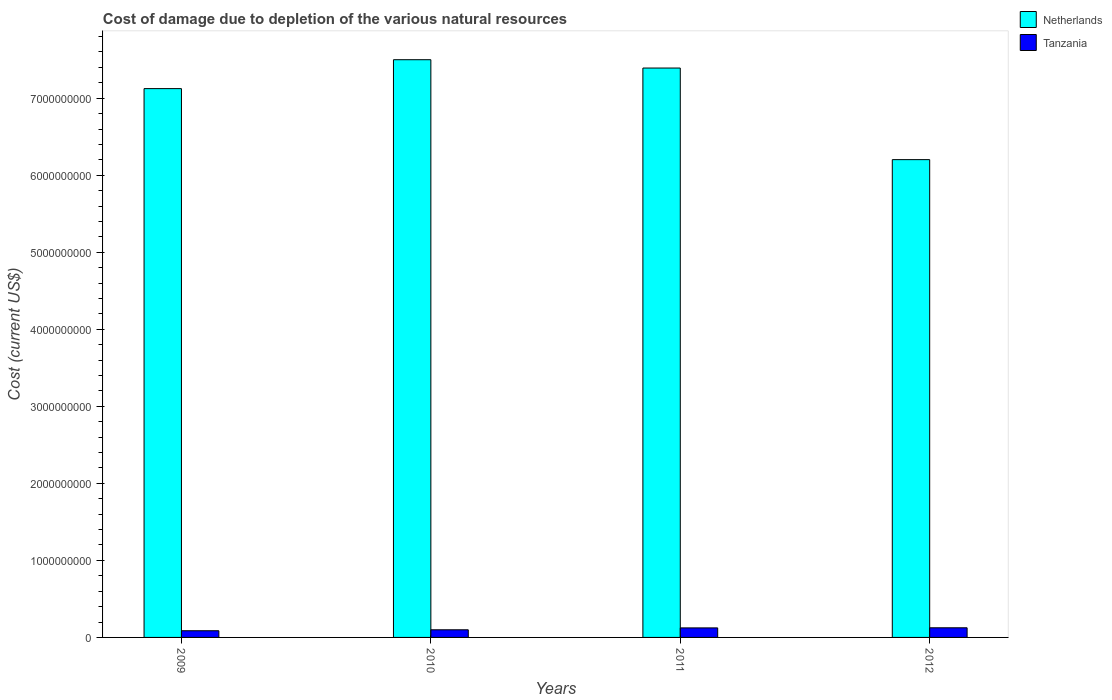How many different coloured bars are there?
Offer a terse response. 2. How many groups of bars are there?
Your response must be concise. 4. Are the number of bars per tick equal to the number of legend labels?
Your response must be concise. Yes. How many bars are there on the 1st tick from the right?
Your answer should be very brief. 2. What is the label of the 4th group of bars from the left?
Provide a succinct answer. 2012. What is the cost of damage caused due to the depletion of various natural resources in Netherlands in 2009?
Ensure brevity in your answer.  7.12e+09. Across all years, what is the maximum cost of damage caused due to the depletion of various natural resources in Tanzania?
Give a very brief answer. 1.25e+08. Across all years, what is the minimum cost of damage caused due to the depletion of various natural resources in Netherlands?
Offer a terse response. 6.20e+09. In which year was the cost of damage caused due to the depletion of various natural resources in Tanzania maximum?
Keep it short and to the point. 2012. In which year was the cost of damage caused due to the depletion of various natural resources in Netherlands minimum?
Provide a succinct answer. 2012. What is the total cost of damage caused due to the depletion of various natural resources in Netherlands in the graph?
Your answer should be compact. 2.82e+1. What is the difference between the cost of damage caused due to the depletion of various natural resources in Tanzania in 2009 and that in 2011?
Provide a succinct answer. -3.69e+07. What is the difference between the cost of damage caused due to the depletion of various natural resources in Netherlands in 2011 and the cost of damage caused due to the depletion of various natural resources in Tanzania in 2010?
Give a very brief answer. 7.29e+09. What is the average cost of damage caused due to the depletion of various natural resources in Tanzania per year?
Your answer should be compact. 1.09e+08. In the year 2011, what is the difference between the cost of damage caused due to the depletion of various natural resources in Tanzania and cost of damage caused due to the depletion of various natural resources in Netherlands?
Give a very brief answer. -7.27e+09. In how many years, is the cost of damage caused due to the depletion of various natural resources in Netherlands greater than 3400000000 US$?
Give a very brief answer. 4. What is the ratio of the cost of damage caused due to the depletion of various natural resources in Netherlands in 2009 to that in 2010?
Offer a terse response. 0.95. Is the cost of damage caused due to the depletion of various natural resources in Tanzania in 2009 less than that in 2011?
Your answer should be very brief. Yes. Is the difference between the cost of damage caused due to the depletion of various natural resources in Tanzania in 2010 and 2012 greater than the difference between the cost of damage caused due to the depletion of various natural resources in Netherlands in 2010 and 2012?
Make the answer very short. No. What is the difference between the highest and the second highest cost of damage caused due to the depletion of various natural resources in Netherlands?
Give a very brief answer. 1.08e+08. What is the difference between the highest and the lowest cost of damage caused due to the depletion of various natural resources in Tanzania?
Offer a terse response. 3.82e+07. In how many years, is the cost of damage caused due to the depletion of various natural resources in Netherlands greater than the average cost of damage caused due to the depletion of various natural resources in Netherlands taken over all years?
Offer a very short reply. 3. Is the sum of the cost of damage caused due to the depletion of various natural resources in Tanzania in 2010 and 2011 greater than the maximum cost of damage caused due to the depletion of various natural resources in Netherlands across all years?
Your answer should be compact. No. What does the 2nd bar from the left in 2010 represents?
Provide a succinct answer. Tanzania. What does the 1st bar from the right in 2011 represents?
Keep it short and to the point. Tanzania. How many bars are there?
Your answer should be compact. 8. Are the values on the major ticks of Y-axis written in scientific E-notation?
Keep it short and to the point. No. What is the title of the graph?
Your answer should be compact. Cost of damage due to depletion of the various natural resources. What is the label or title of the X-axis?
Your response must be concise. Years. What is the label or title of the Y-axis?
Give a very brief answer. Cost (current US$). What is the Cost (current US$) of Netherlands in 2009?
Your answer should be very brief. 7.12e+09. What is the Cost (current US$) of Tanzania in 2009?
Provide a short and direct response. 8.69e+07. What is the Cost (current US$) of Netherlands in 2010?
Provide a succinct answer. 7.50e+09. What is the Cost (current US$) of Tanzania in 2010?
Ensure brevity in your answer.  9.92e+07. What is the Cost (current US$) of Netherlands in 2011?
Offer a terse response. 7.39e+09. What is the Cost (current US$) of Tanzania in 2011?
Your response must be concise. 1.24e+08. What is the Cost (current US$) of Netherlands in 2012?
Your response must be concise. 6.20e+09. What is the Cost (current US$) of Tanzania in 2012?
Offer a terse response. 1.25e+08. Across all years, what is the maximum Cost (current US$) in Netherlands?
Provide a succinct answer. 7.50e+09. Across all years, what is the maximum Cost (current US$) in Tanzania?
Keep it short and to the point. 1.25e+08. Across all years, what is the minimum Cost (current US$) of Netherlands?
Provide a short and direct response. 6.20e+09. Across all years, what is the minimum Cost (current US$) in Tanzania?
Provide a succinct answer. 8.69e+07. What is the total Cost (current US$) in Netherlands in the graph?
Offer a very short reply. 2.82e+1. What is the total Cost (current US$) in Tanzania in the graph?
Your response must be concise. 4.35e+08. What is the difference between the Cost (current US$) in Netherlands in 2009 and that in 2010?
Your answer should be compact. -3.75e+08. What is the difference between the Cost (current US$) of Tanzania in 2009 and that in 2010?
Your answer should be very brief. -1.23e+07. What is the difference between the Cost (current US$) of Netherlands in 2009 and that in 2011?
Your response must be concise. -2.67e+08. What is the difference between the Cost (current US$) of Tanzania in 2009 and that in 2011?
Make the answer very short. -3.69e+07. What is the difference between the Cost (current US$) of Netherlands in 2009 and that in 2012?
Offer a very short reply. 9.22e+08. What is the difference between the Cost (current US$) in Tanzania in 2009 and that in 2012?
Provide a short and direct response. -3.82e+07. What is the difference between the Cost (current US$) of Netherlands in 2010 and that in 2011?
Make the answer very short. 1.08e+08. What is the difference between the Cost (current US$) in Tanzania in 2010 and that in 2011?
Offer a terse response. -2.46e+07. What is the difference between the Cost (current US$) in Netherlands in 2010 and that in 2012?
Your answer should be very brief. 1.30e+09. What is the difference between the Cost (current US$) of Tanzania in 2010 and that in 2012?
Ensure brevity in your answer.  -2.59e+07. What is the difference between the Cost (current US$) of Netherlands in 2011 and that in 2012?
Provide a short and direct response. 1.19e+09. What is the difference between the Cost (current US$) in Tanzania in 2011 and that in 2012?
Offer a very short reply. -1.27e+06. What is the difference between the Cost (current US$) in Netherlands in 2009 and the Cost (current US$) in Tanzania in 2010?
Provide a succinct answer. 7.03e+09. What is the difference between the Cost (current US$) of Netherlands in 2009 and the Cost (current US$) of Tanzania in 2011?
Ensure brevity in your answer.  7.00e+09. What is the difference between the Cost (current US$) of Netherlands in 2009 and the Cost (current US$) of Tanzania in 2012?
Offer a very short reply. 7.00e+09. What is the difference between the Cost (current US$) of Netherlands in 2010 and the Cost (current US$) of Tanzania in 2011?
Provide a succinct answer. 7.38e+09. What is the difference between the Cost (current US$) of Netherlands in 2010 and the Cost (current US$) of Tanzania in 2012?
Your answer should be compact. 7.37e+09. What is the difference between the Cost (current US$) of Netherlands in 2011 and the Cost (current US$) of Tanzania in 2012?
Ensure brevity in your answer.  7.27e+09. What is the average Cost (current US$) of Netherlands per year?
Your answer should be very brief. 7.05e+09. What is the average Cost (current US$) in Tanzania per year?
Your answer should be very brief. 1.09e+08. In the year 2009, what is the difference between the Cost (current US$) of Netherlands and Cost (current US$) of Tanzania?
Your answer should be very brief. 7.04e+09. In the year 2010, what is the difference between the Cost (current US$) in Netherlands and Cost (current US$) in Tanzania?
Provide a succinct answer. 7.40e+09. In the year 2011, what is the difference between the Cost (current US$) of Netherlands and Cost (current US$) of Tanzania?
Keep it short and to the point. 7.27e+09. In the year 2012, what is the difference between the Cost (current US$) of Netherlands and Cost (current US$) of Tanzania?
Your response must be concise. 6.08e+09. What is the ratio of the Cost (current US$) of Tanzania in 2009 to that in 2010?
Offer a very short reply. 0.88. What is the ratio of the Cost (current US$) of Netherlands in 2009 to that in 2011?
Your answer should be very brief. 0.96. What is the ratio of the Cost (current US$) in Tanzania in 2009 to that in 2011?
Ensure brevity in your answer.  0.7. What is the ratio of the Cost (current US$) in Netherlands in 2009 to that in 2012?
Give a very brief answer. 1.15. What is the ratio of the Cost (current US$) in Tanzania in 2009 to that in 2012?
Offer a very short reply. 0.69. What is the ratio of the Cost (current US$) of Netherlands in 2010 to that in 2011?
Your response must be concise. 1.01. What is the ratio of the Cost (current US$) of Tanzania in 2010 to that in 2011?
Offer a terse response. 0.8. What is the ratio of the Cost (current US$) in Netherlands in 2010 to that in 2012?
Your response must be concise. 1.21. What is the ratio of the Cost (current US$) in Tanzania in 2010 to that in 2012?
Ensure brevity in your answer.  0.79. What is the ratio of the Cost (current US$) in Netherlands in 2011 to that in 2012?
Ensure brevity in your answer.  1.19. What is the difference between the highest and the second highest Cost (current US$) of Netherlands?
Provide a short and direct response. 1.08e+08. What is the difference between the highest and the second highest Cost (current US$) in Tanzania?
Your response must be concise. 1.27e+06. What is the difference between the highest and the lowest Cost (current US$) of Netherlands?
Provide a succinct answer. 1.30e+09. What is the difference between the highest and the lowest Cost (current US$) in Tanzania?
Provide a short and direct response. 3.82e+07. 